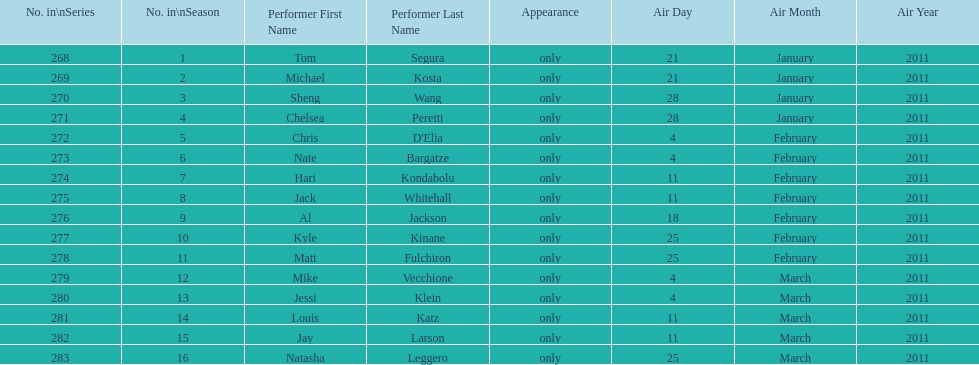Who appeared first tom segura or jay larson? Tom Segura. 